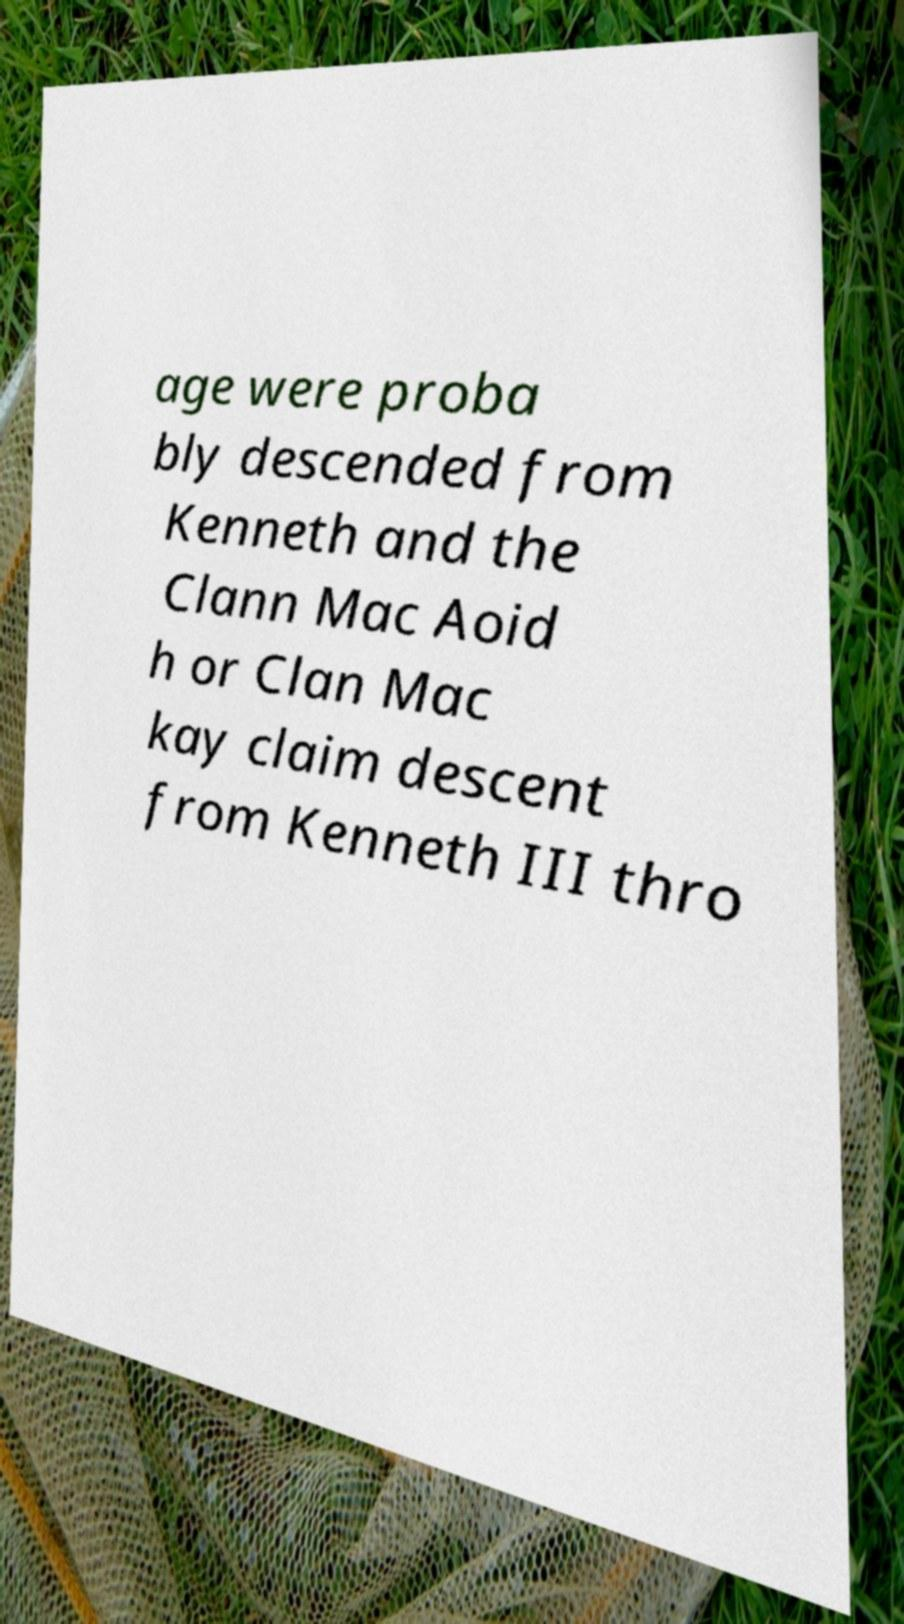There's text embedded in this image that I need extracted. Can you transcribe it verbatim? age were proba bly descended from Kenneth and the Clann Mac Aoid h or Clan Mac kay claim descent from Kenneth III thro 